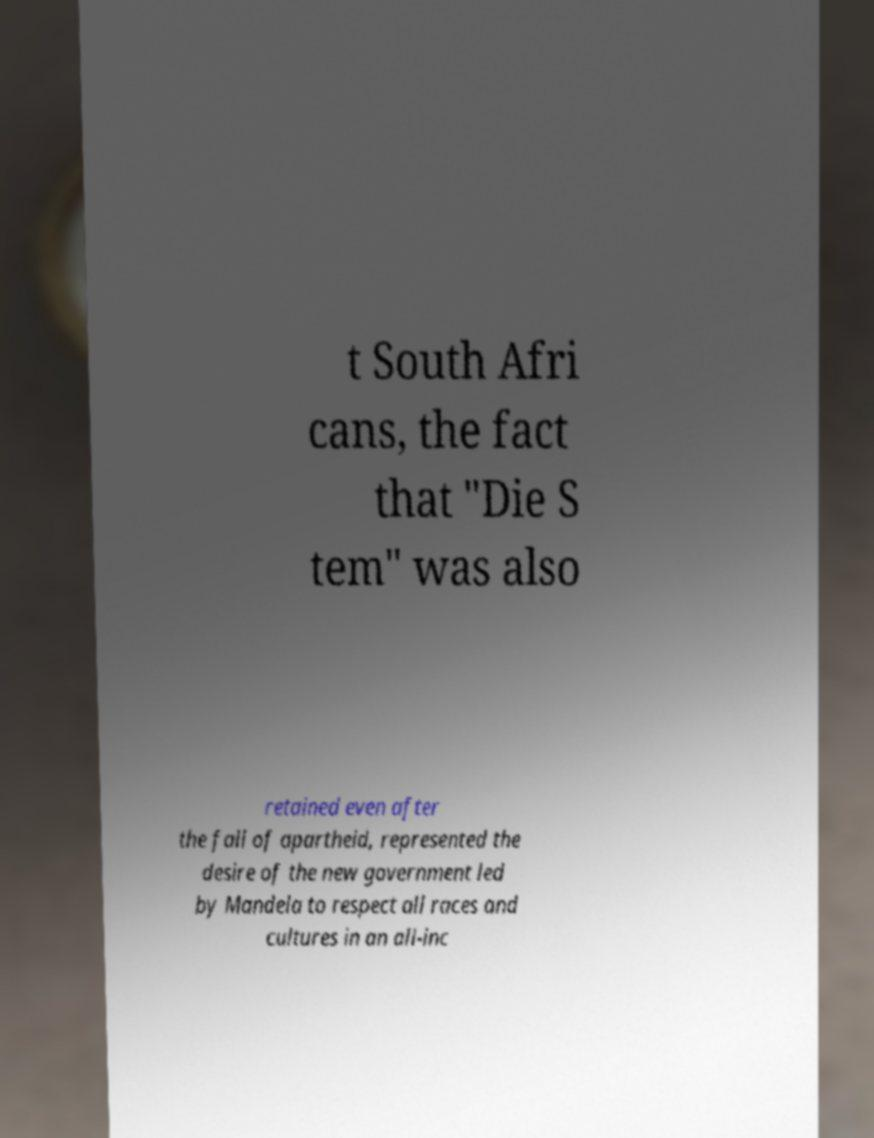Can you read and provide the text displayed in the image?This photo seems to have some interesting text. Can you extract and type it out for me? t South Afri cans, the fact that "Die S tem" was also retained even after the fall of apartheid, represented the desire of the new government led by Mandela to respect all races and cultures in an all-inc 